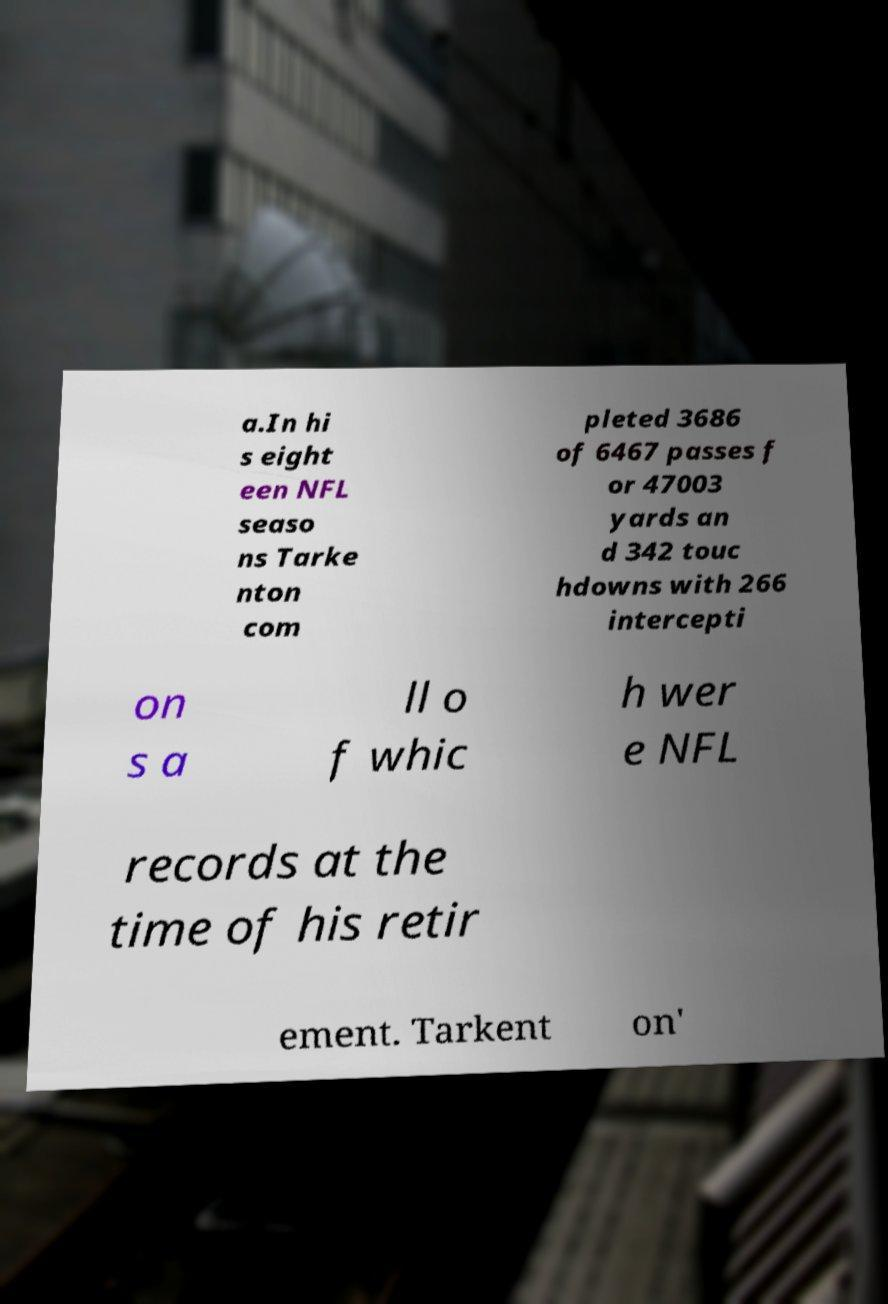For documentation purposes, I need the text within this image transcribed. Could you provide that? a.In hi s eight een NFL seaso ns Tarke nton com pleted 3686 of 6467 passes f or 47003 yards an d 342 touc hdowns with 266 intercepti on s a ll o f whic h wer e NFL records at the time of his retir ement. Tarkent on' 